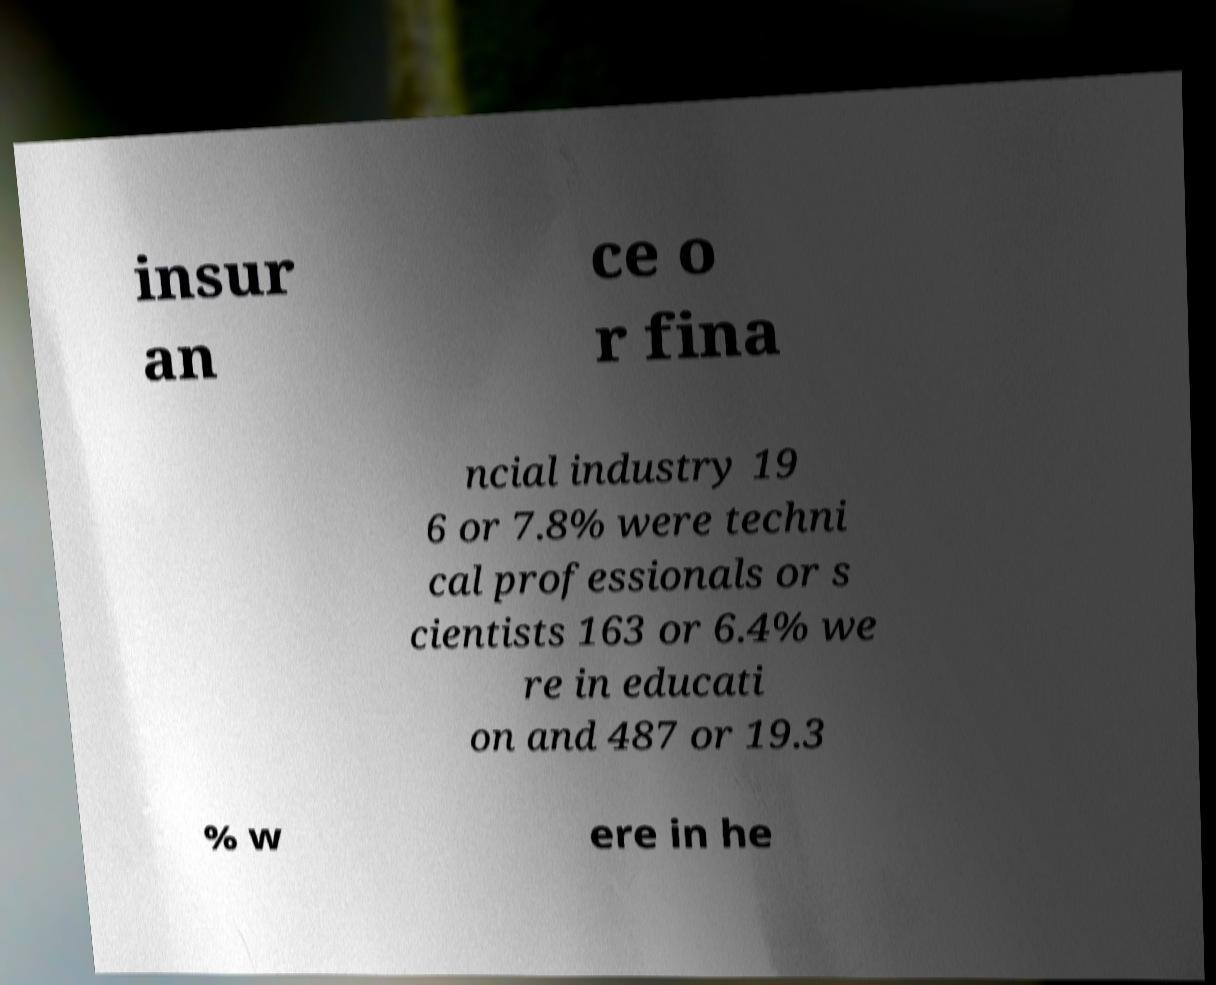I need the written content from this picture converted into text. Can you do that? insur an ce o r fina ncial industry 19 6 or 7.8% were techni cal professionals or s cientists 163 or 6.4% we re in educati on and 487 or 19.3 % w ere in he 